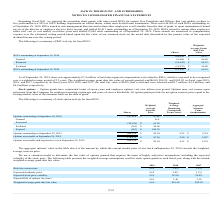According to Jack In The Box's financial document, What is the weighted-average grant date fair value of awards granted in fiscal year 2017? According to the financial document, $102.42. The relevant text states: "ir value of awards granted was $86.08, $94.93, and $102.42 in fiscal years 2019, 2018, and 2017, respectively. In fiscal years 2019, 2018, and 2017, the total..." Also, What is the total fair value of RSUs that were vested and released in fiscal year 2019? According to the financial document, $4.7 million. The relevant text states: "ir value of RSUs that vested and were released was $4.7 million, $4.4 million, and $4.4 million, respectively...." Also, What is the total number of RSUs outstanding at September 29, 2019? According to the financial document, 311,845. The relevant text states: "RSUs outstanding at September 29, 2019 311,845 $ 66.18..." Also, can you calculate: What is the difference in the weighted-average grant date fair value between granted RSUs and released RSUs? Based on the calculation: 86.08-84.23, the result is 1.85. This is based on the information: "Granted 93,686 $ 86.08 Released (55,642) $ 84.23..." The key data points involved are: 84.23, 86.08. Also, can you calculate: What is the percentage change of RSUs outstanding from September 30, 2018 to September 29, 2019? To answer this question, I need to perform calculations using the financial data. The calculation is: (311,845-288,098)/288,098, which equals 8.24 (percentage). This is based on the information: "RSUs outstanding at September 29, 2019 311,845 $ 66.18 RSUs outstanding at September 30, 2018 288,098 $ 64.57..." The key data points involved are: 288,098, 311,845. Also, can you calculate: What is the total fair value of RSUs outstanding at September 29, 2019? Based on the calculation: 311,845*$66.18, the result is 20637902.1. This is based on the information: "RSUs outstanding at September 29, 2019 311,845 $ 66.18 RSUs outstanding at September 29, 2019 311,845 $ 66.18..." The key data points involved are: 311,845, 66.18. 